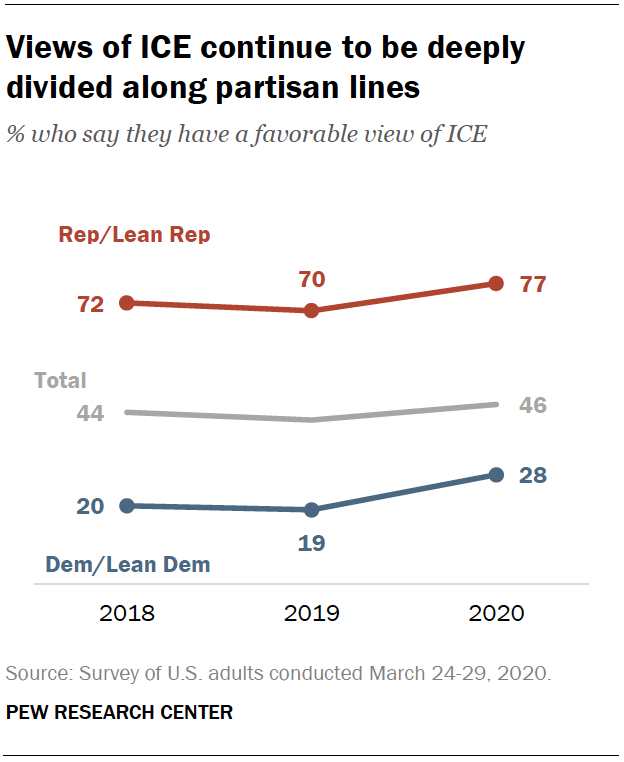Identify some key points in this picture. In 2019, the ratio of Representative Democrats to Representative Republicans was 3.5, and the ratio of Democratic-leaning Representatives to Democratic-leaning Representatives was 2.2 in 2018. The lowest value of the red graph is 70. 